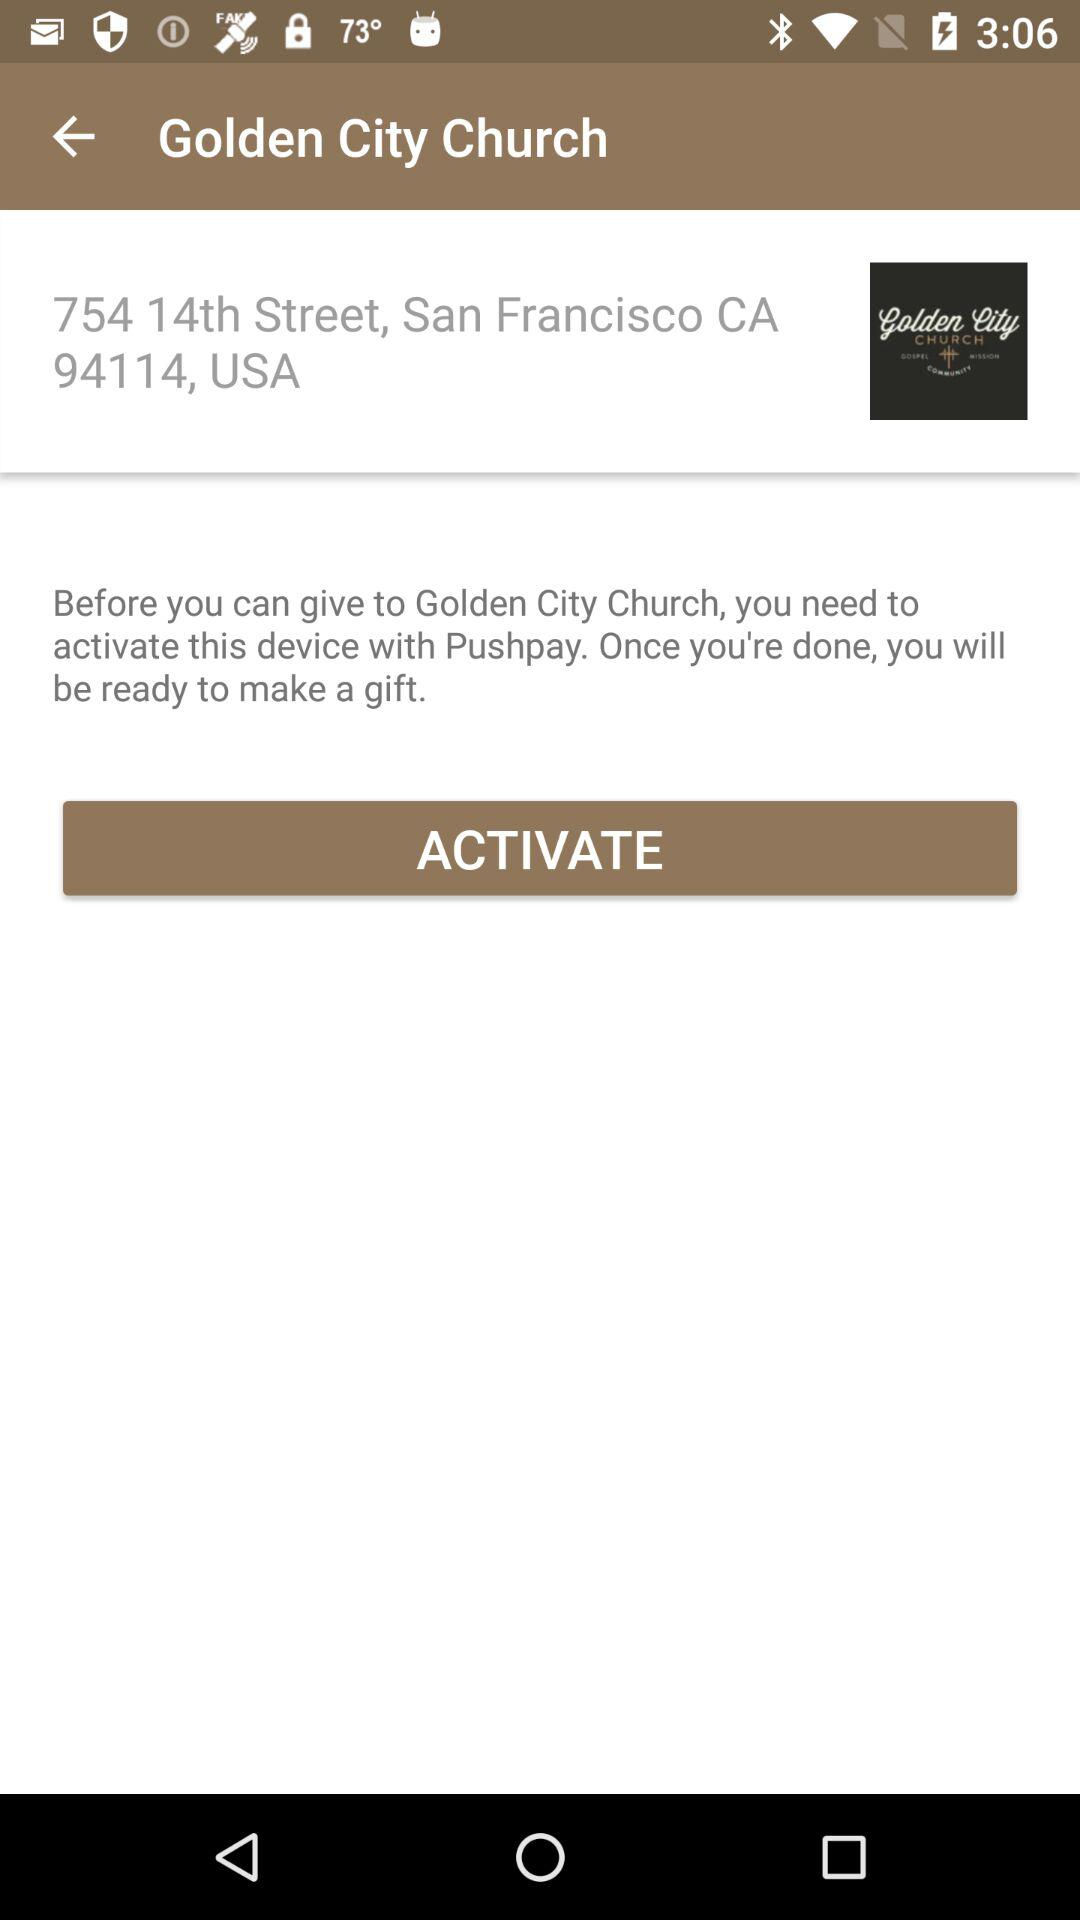What is the given location? The location is 754 14th Street, San Francisco, CA 94114, USA. 